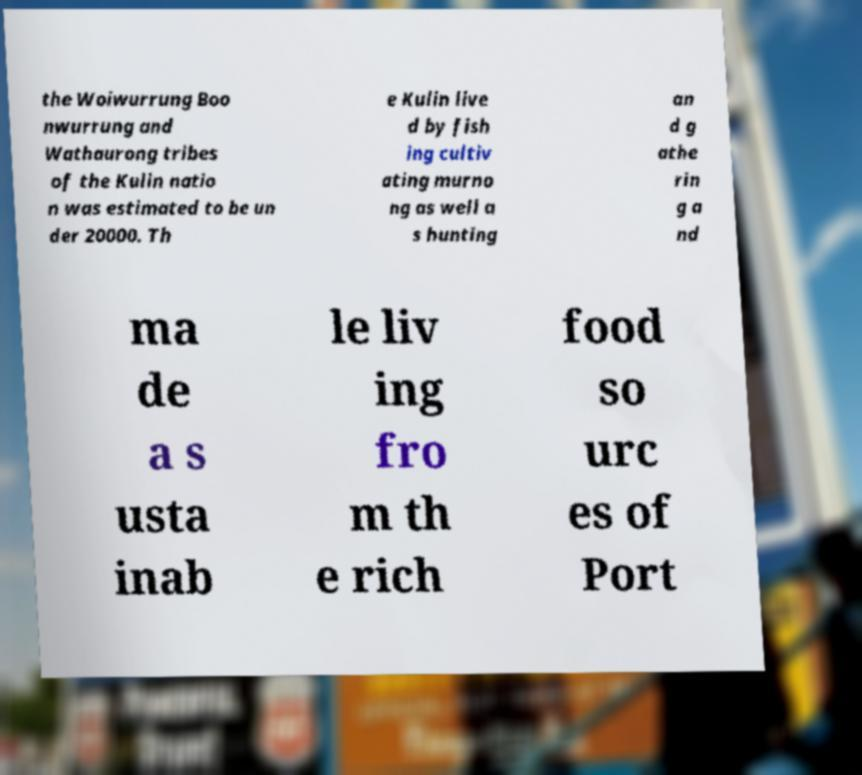Please identify and transcribe the text found in this image. the Woiwurrung Boo nwurrung and Wathaurong tribes of the Kulin natio n was estimated to be un der 20000. Th e Kulin live d by fish ing cultiv ating murno ng as well a s hunting an d g athe rin g a nd ma de a s usta inab le liv ing fro m th e rich food so urc es of Port 